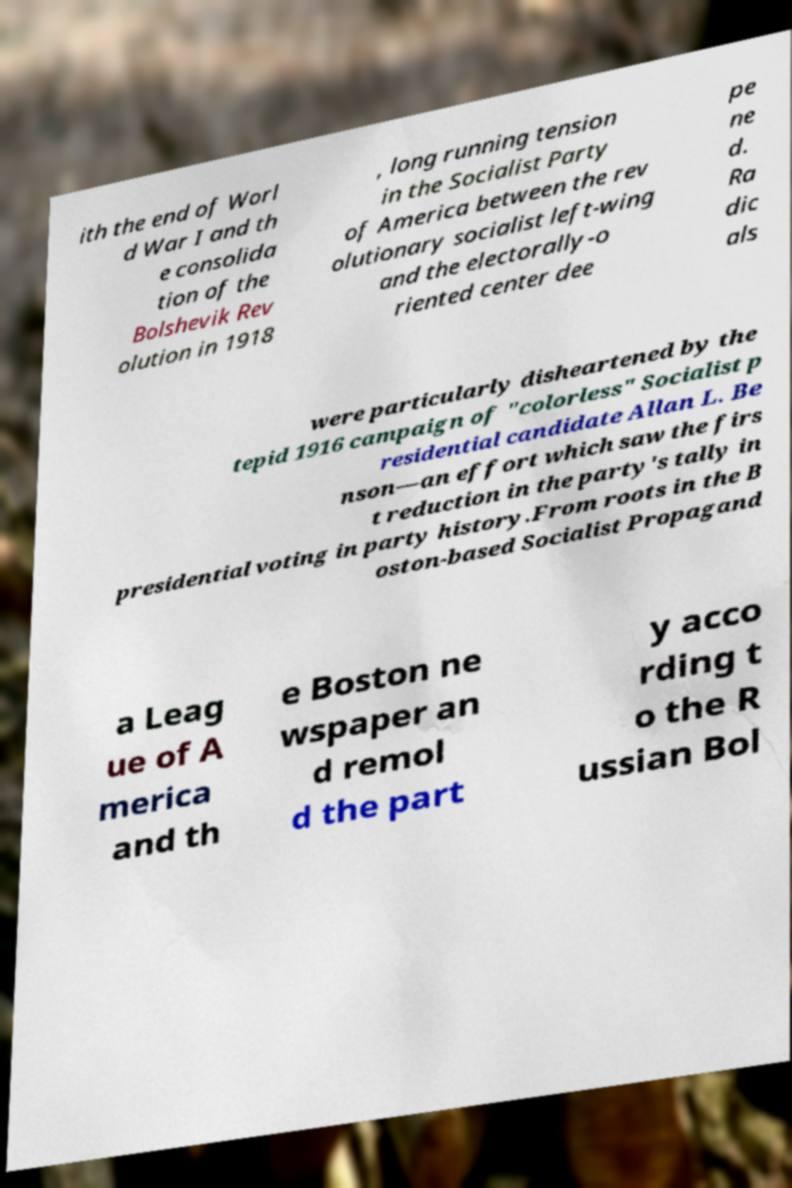Could you assist in decoding the text presented in this image and type it out clearly? ith the end of Worl d War I and th e consolida tion of the Bolshevik Rev olution in 1918 , long running tension in the Socialist Party of America between the rev olutionary socialist left-wing and the electorally-o riented center dee pe ne d. Ra dic als were particularly disheartened by the tepid 1916 campaign of "colorless" Socialist p residential candidate Allan L. Be nson—an effort which saw the firs t reduction in the party's tally in presidential voting in party history.From roots in the B oston-based Socialist Propagand a Leag ue of A merica and th e Boston ne wspaper an d remol d the part y acco rding t o the R ussian Bol 